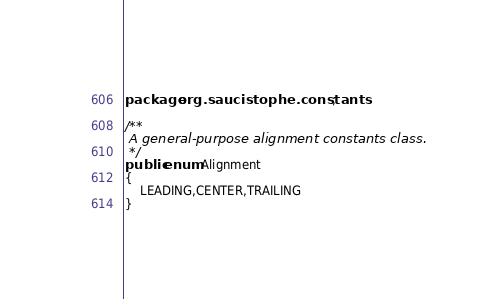<code> <loc_0><loc_0><loc_500><loc_500><_Java_>package org.saucistophe.constants;

/**
 A general-purpose alignment constants class.
 */
public enum Alignment
{
	LEADING,CENTER,TRAILING
}
</code> 